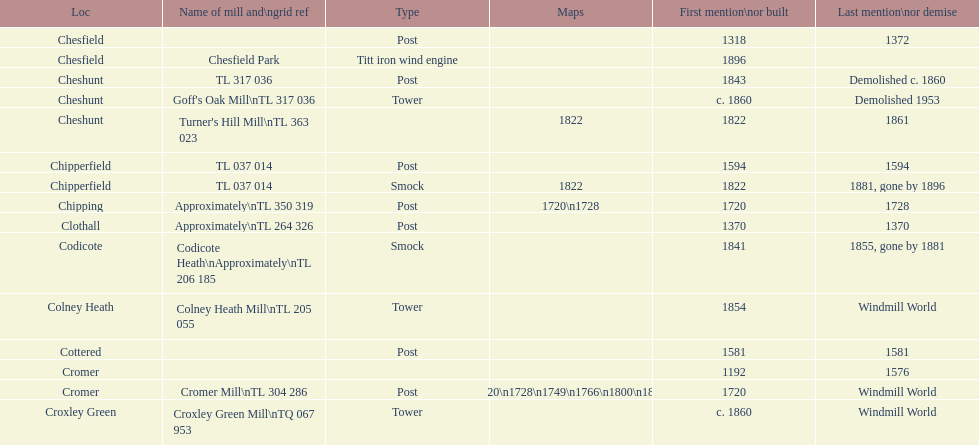Did cromer, chipperfield or cheshunt have the most windmills? Cheshunt. 